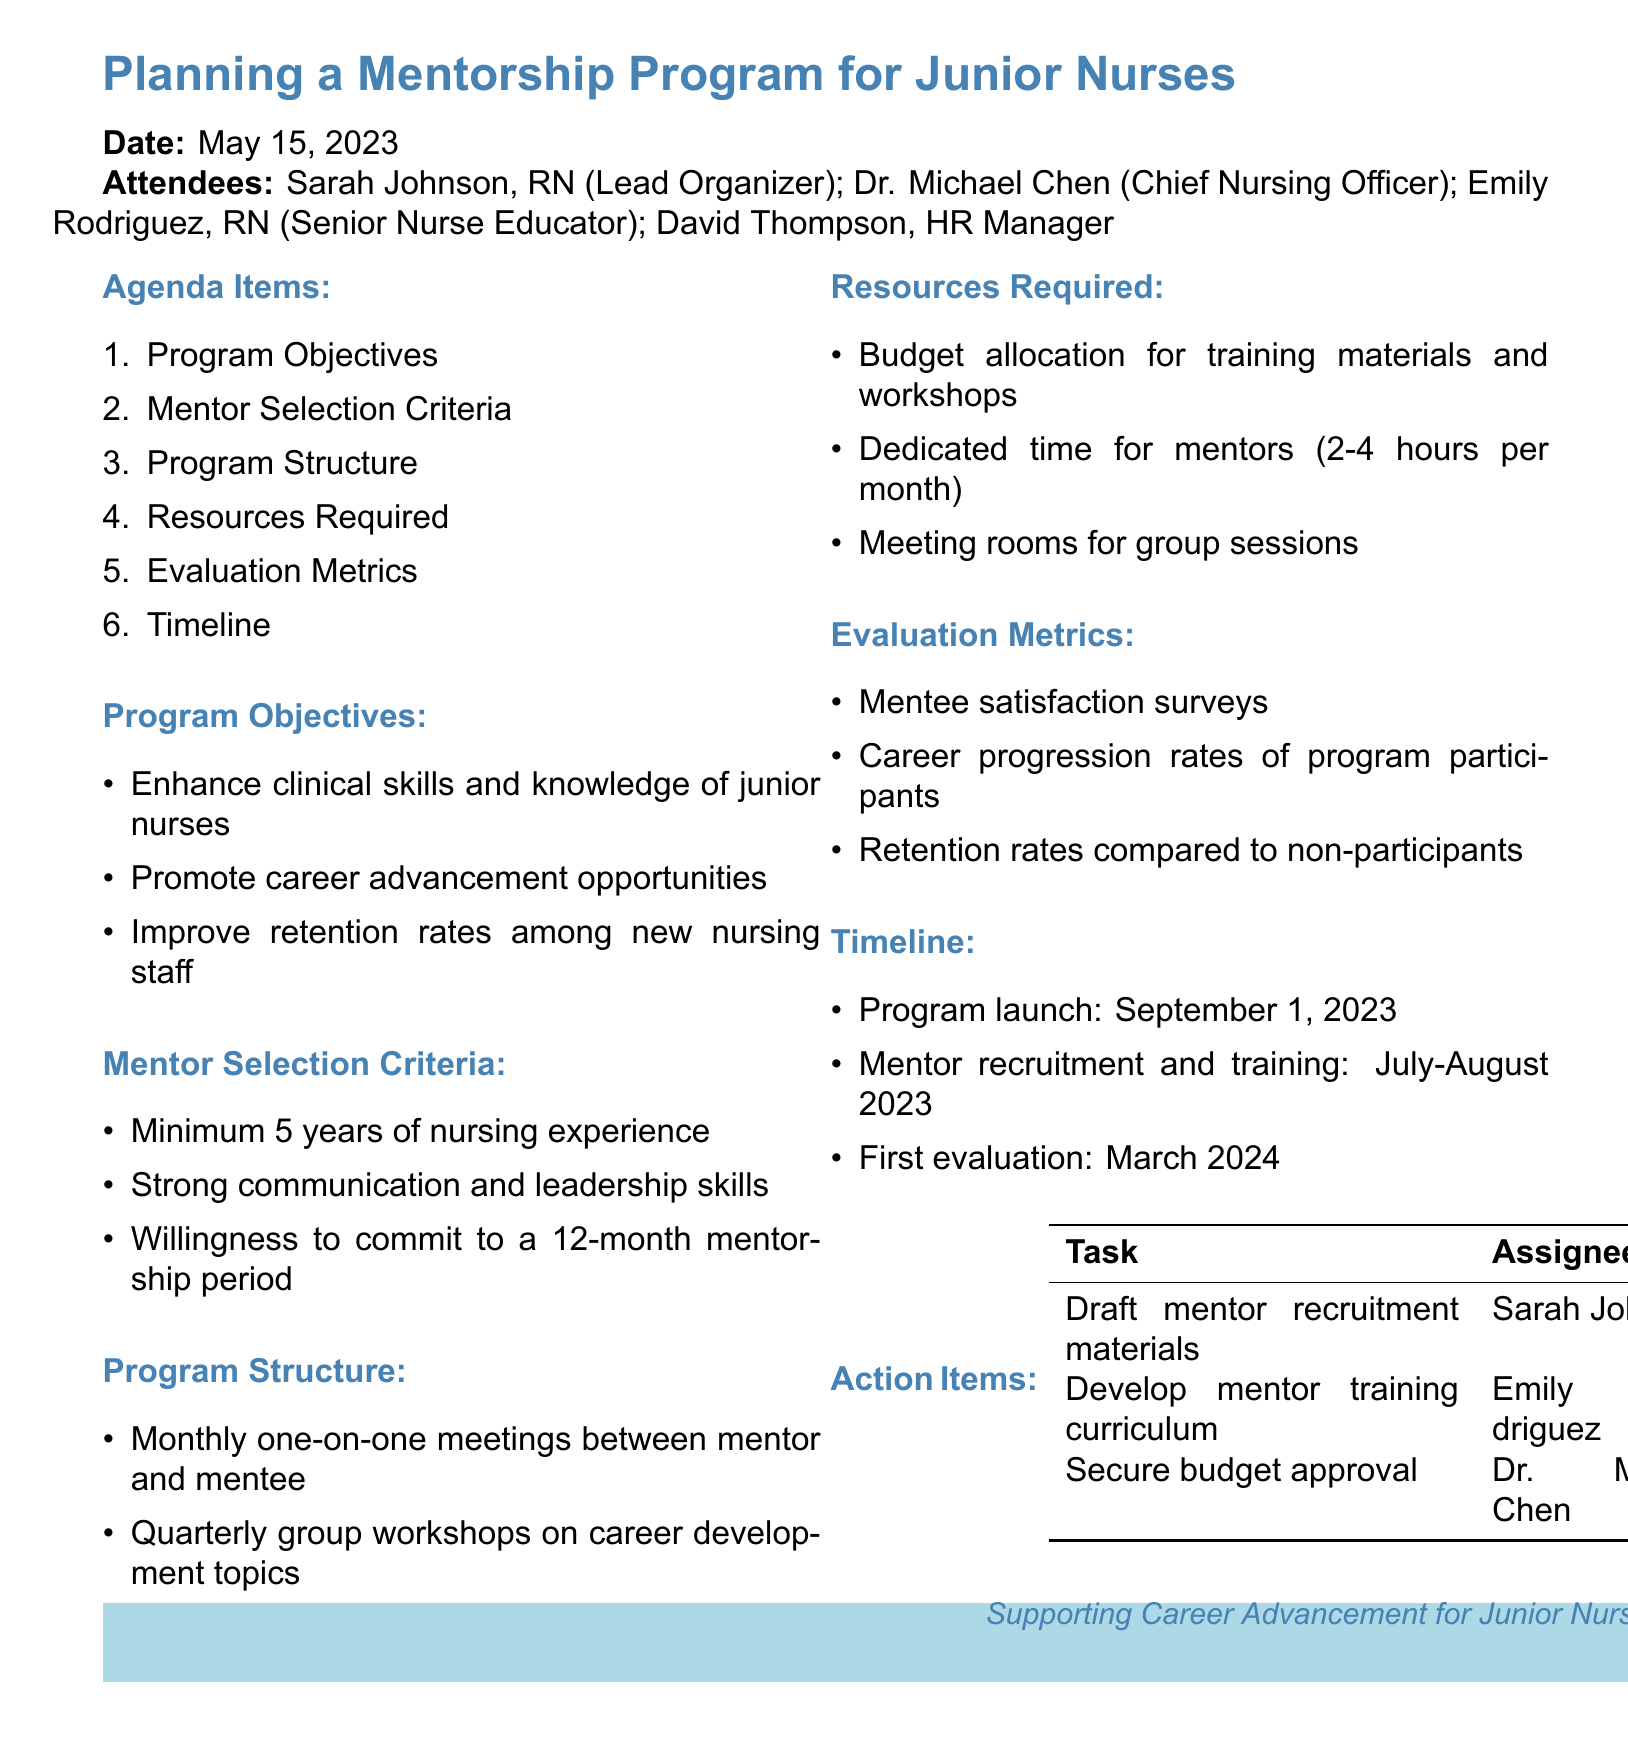What are the program objectives? The program objectives are listed in the agenda items section of the document.
Answer: Enhance clinical skills and knowledge of junior nurses, Promote career advancement opportunities, Improve retention rates among new nursing staff Who is the lead organizer of the mentorship program? The lead organizer is mentioned in the attendees section of the document.
Answer: Sarah Johnson What is the mentor selection criterion regarding experience? The mentor selection criteria provide specific requirements for potential mentors.
Answer: Minimum 5 years of nursing experience When is the program launch date? The timeline section specifies key dates for the mentorship program.
Answer: September 1, 2023 What resources are required for the mentorship program? The resources required are detailed in a specific agenda item in the document.
Answer: Budget allocation for training materials and workshops, Dedicated time for mentors, Meeting rooms for group sessions How many hours per month are mentors expected to dedicate? The resources required section specifies the expected commitment from mentors.
Answer: 2-4 hours per month What is the first evaluation date for the program? The first evaluation date is mentioned in the timeline section of the document.
Answer: March 2024 Who is responsible for drafting mentor recruitment materials? The action items section details responsibilities for various tasks associated with the program.
Answer: Sarah Johnson What is one of the evaluation metrics for the program? Evaluation metrics are discussed in a specific agenda item, listing the methods for assessing the program's effectiveness.
Answer: Mentee satisfaction surveys 